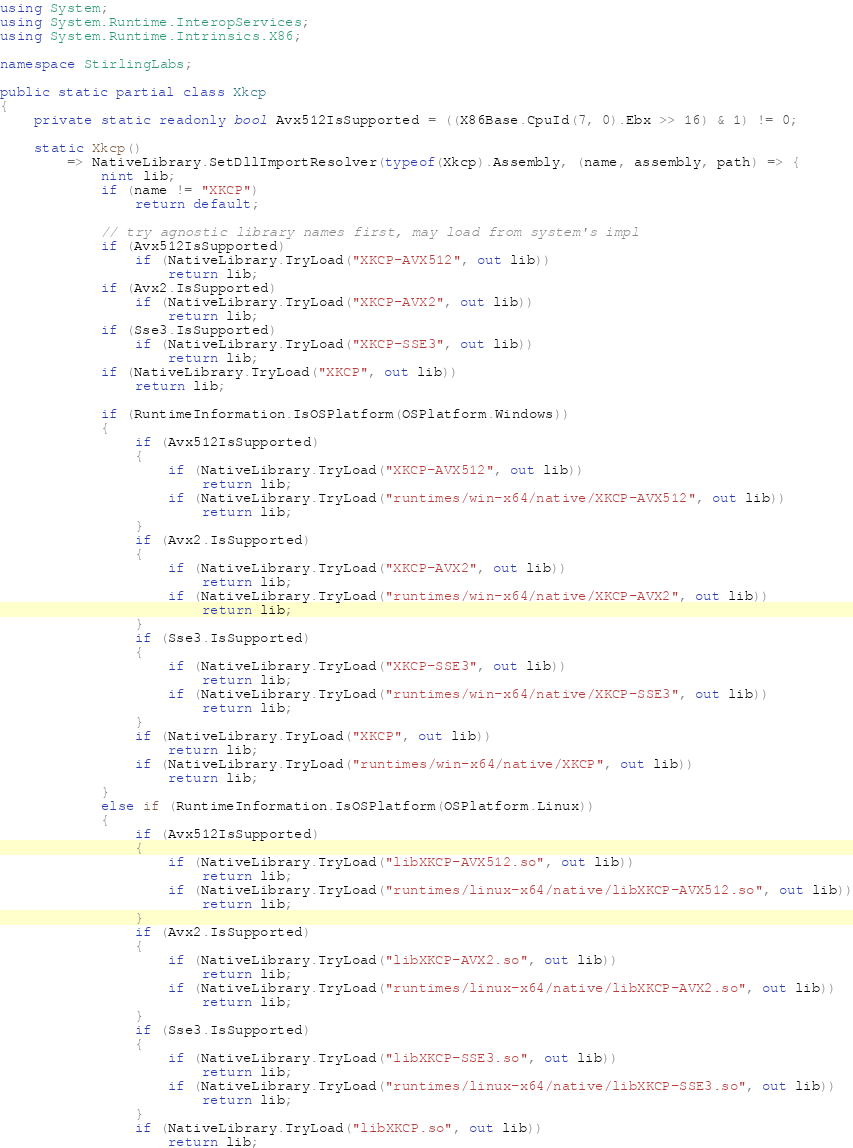<code> <loc_0><loc_0><loc_500><loc_500><_C#_>using System;
using System.Runtime.InteropServices;
using System.Runtime.Intrinsics.X86;

namespace StirlingLabs; 

public static partial class Xkcp
{
    private static readonly bool Avx512IsSupported = ((X86Base.CpuId(7, 0).Ebx >> 16) & 1) != 0;

    static Xkcp()
        => NativeLibrary.SetDllImportResolver(typeof(Xkcp).Assembly, (name, assembly, path) => {
            nint lib;
            if (name != "XKCP")
                return default;

            // try agnostic library names first, may load from system's impl
            if (Avx512IsSupported)
                if (NativeLibrary.TryLoad("XKCP-AVX512", out lib))
                    return lib;
            if (Avx2.IsSupported)
                if (NativeLibrary.TryLoad("XKCP-AVX2", out lib))
                    return lib;
            if (Sse3.IsSupported)
                if (NativeLibrary.TryLoad("XKCP-SSE3", out lib))
                    return lib;
            if (NativeLibrary.TryLoad("XKCP", out lib))
                return lib;

            if (RuntimeInformation.IsOSPlatform(OSPlatform.Windows))
            {
                if (Avx512IsSupported)
                {
                    if (NativeLibrary.TryLoad("XKCP-AVX512", out lib))
                        return lib;
                    if (NativeLibrary.TryLoad("runtimes/win-x64/native/XKCP-AVX512", out lib))
                        return lib;
                }
                if (Avx2.IsSupported)
                {
                    if (NativeLibrary.TryLoad("XKCP-AVX2", out lib))
                        return lib;
                    if (NativeLibrary.TryLoad("runtimes/win-x64/native/XKCP-AVX2", out lib))
                        return lib;
                }
                if (Sse3.IsSupported)
                {
                    if (NativeLibrary.TryLoad("XKCP-SSE3", out lib))
                        return lib;
                    if (NativeLibrary.TryLoad("runtimes/win-x64/native/XKCP-SSE3", out lib))
                        return lib;
                }
                if (NativeLibrary.TryLoad("XKCP", out lib))
                    return lib;
                if (NativeLibrary.TryLoad("runtimes/win-x64/native/XKCP", out lib))
                    return lib;
            }
            else if (RuntimeInformation.IsOSPlatform(OSPlatform.Linux))
            {
                if (Avx512IsSupported)
                {
                    if (NativeLibrary.TryLoad("libXKCP-AVX512.so", out lib))
                        return lib;
                    if (NativeLibrary.TryLoad("runtimes/linux-x64/native/libXKCP-AVX512.so", out lib))
                        return lib;
                }
                if (Avx2.IsSupported)
                {
                    if (NativeLibrary.TryLoad("libXKCP-AVX2.so", out lib))
                        return lib;
                    if (NativeLibrary.TryLoad("runtimes/linux-x64/native/libXKCP-AVX2.so", out lib))
                        return lib;
                }
                if (Sse3.IsSupported)
                {
                    if (NativeLibrary.TryLoad("libXKCP-SSE3.so", out lib))
                        return lib;
                    if (NativeLibrary.TryLoad("runtimes/linux-x64/native/libXKCP-SSE3.so", out lib))
                        return lib;
                }
                if (NativeLibrary.TryLoad("libXKCP.so", out lib))
                    return lib;</code> 